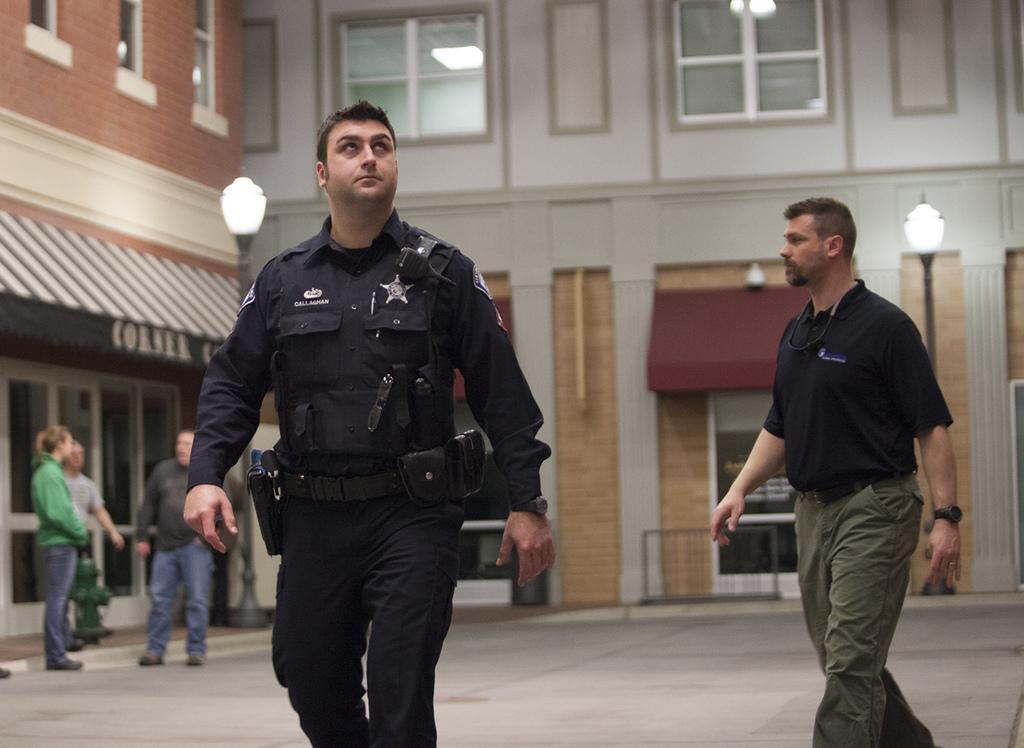In one or two sentences, can you explain what this image depicts? At the bottom of the image there is a floor. In the middle of the image two men are walking on the floor. On the left side of the image two men and a woman are standing on the floor and there is a hydrant. In the background there are two buildings with walls, windows and doors. There is a board with a text on it and there are two street lights. 